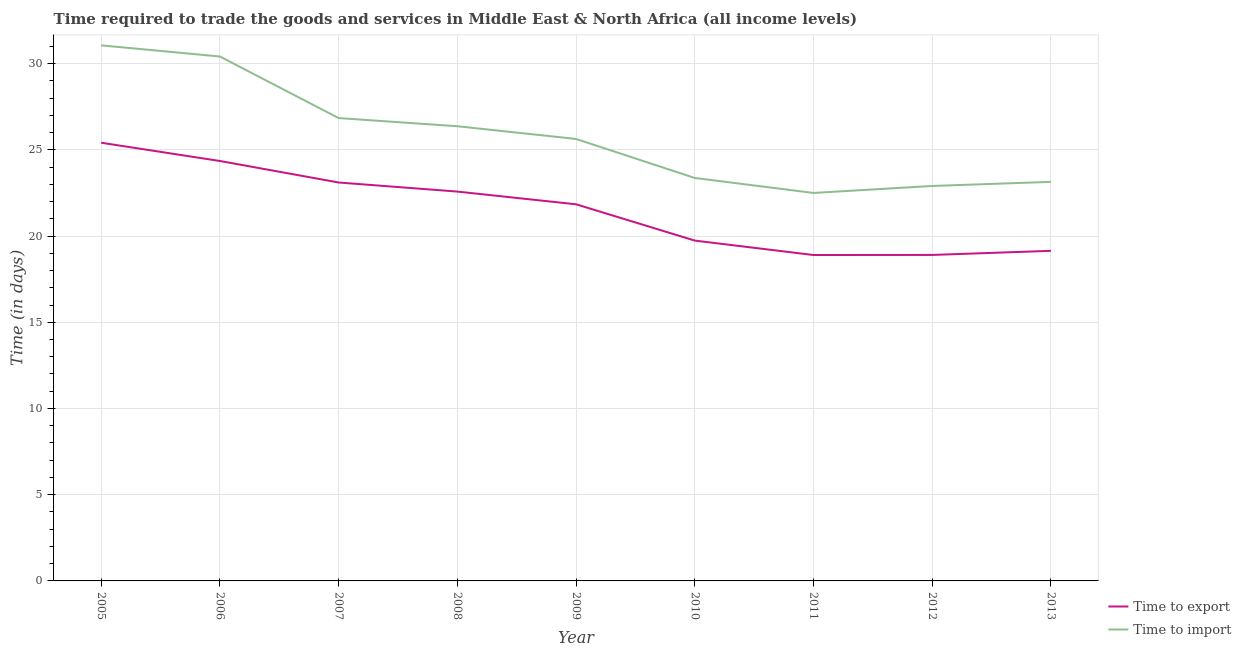How many different coloured lines are there?
Give a very brief answer. 2. Does the line corresponding to time to export intersect with the line corresponding to time to import?
Keep it short and to the point. No. Is the number of lines equal to the number of legend labels?
Keep it short and to the point. Yes. What is the time to export in 2006?
Give a very brief answer. 24.35. Across all years, what is the maximum time to export?
Provide a short and direct response. 25.41. What is the total time to export in the graph?
Give a very brief answer. 193.98. What is the difference between the time to export in 2008 and that in 2011?
Provide a short and direct response. 3.68. What is the difference between the time to import in 2007 and the time to export in 2008?
Give a very brief answer. 4.26. What is the average time to export per year?
Provide a short and direct response. 21.55. In the year 2008, what is the difference between the time to export and time to import?
Offer a terse response. -3.79. What is the ratio of the time to import in 2008 to that in 2013?
Ensure brevity in your answer.  1.14. Is the difference between the time to export in 2010 and 2012 greater than the difference between the time to import in 2010 and 2012?
Offer a terse response. Yes. What is the difference between the highest and the second highest time to import?
Offer a very short reply. 0.65. What is the difference between the highest and the lowest time to export?
Your answer should be compact. 6.51. In how many years, is the time to import greater than the average time to import taken over all years?
Provide a succinct answer. 4. Is the sum of the time to import in 2007 and 2011 greater than the maximum time to export across all years?
Your answer should be compact. Yes. Does the time to import monotonically increase over the years?
Offer a terse response. No. Is the time to import strictly less than the time to export over the years?
Offer a terse response. No. How many lines are there?
Offer a very short reply. 2. What is the difference between two consecutive major ticks on the Y-axis?
Provide a succinct answer. 5. Are the values on the major ticks of Y-axis written in scientific E-notation?
Your answer should be very brief. No. Does the graph contain grids?
Offer a terse response. Yes. How many legend labels are there?
Offer a very short reply. 2. What is the title of the graph?
Your answer should be compact. Time required to trade the goods and services in Middle East & North Africa (all income levels). What is the label or title of the X-axis?
Your response must be concise. Year. What is the label or title of the Y-axis?
Offer a very short reply. Time (in days). What is the Time (in days) in Time to export in 2005?
Offer a very short reply. 25.41. What is the Time (in days) of Time to import in 2005?
Offer a terse response. 31.06. What is the Time (in days) in Time to export in 2006?
Offer a terse response. 24.35. What is the Time (in days) in Time to import in 2006?
Your response must be concise. 30.41. What is the Time (in days) in Time to export in 2007?
Offer a very short reply. 23.11. What is the Time (in days) of Time to import in 2007?
Your response must be concise. 26.84. What is the Time (in days) of Time to export in 2008?
Offer a very short reply. 22.58. What is the Time (in days) in Time to import in 2008?
Your response must be concise. 26.37. What is the Time (in days) of Time to export in 2009?
Offer a terse response. 21.84. What is the Time (in days) of Time to import in 2009?
Keep it short and to the point. 25.63. What is the Time (in days) of Time to export in 2010?
Your response must be concise. 19.74. What is the Time (in days) of Time to import in 2010?
Provide a short and direct response. 23.37. What is the Time (in days) in Time to export in 2012?
Provide a succinct answer. 18.9. What is the Time (in days) of Time to import in 2012?
Ensure brevity in your answer.  22.9. What is the Time (in days) of Time to export in 2013?
Your answer should be compact. 19.14. What is the Time (in days) in Time to import in 2013?
Your answer should be compact. 23.14. Across all years, what is the maximum Time (in days) of Time to export?
Your answer should be compact. 25.41. Across all years, what is the maximum Time (in days) in Time to import?
Make the answer very short. 31.06. Across all years, what is the minimum Time (in days) in Time to import?
Provide a succinct answer. 22.5. What is the total Time (in days) of Time to export in the graph?
Your response must be concise. 193.98. What is the total Time (in days) in Time to import in the graph?
Offer a very short reply. 232.23. What is the difference between the Time (in days) in Time to export in 2005 and that in 2006?
Offer a terse response. 1.06. What is the difference between the Time (in days) in Time to import in 2005 and that in 2006?
Your response must be concise. 0.65. What is the difference between the Time (in days) in Time to export in 2005 and that in 2007?
Give a very brief answer. 2.31. What is the difference between the Time (in days) in Time to import in 2005 and that in 2007?
Make the answer very short. 4.22. What is the difference between the Time (in days) of Time to export in 2005 and that in 2008?
Offer a very short reply. 2.83. What is the difference between the Time (in days) of Time to import in 2005 and that in 2008?
Provide a succinct answer. 4.69. What is the difference between the Time (in days) of Time to export in 2005 and that in 2009?
Offer a terse response. 3.57. What is the difference between the Time (in days) of Time to import in 2005 and that in 2009?
Keep it short and to the point. 5.43. What is the difference between the Time (in days) in Time to export in 2005 and that in 2010?
Keep it short and to the point. 5.67. What is the difference between the Time (in days) in Time to import in 2005 and that in 2010?
Provide a succinct answer. 7.69. What is the difference between the Time (in days) in Time to export in 2005 and that in 2011?
Keep it short and to the point. 6.51. What is the difference between the Time (in days) of Time to import in 2005 and that in 2011?
Ensure brevity in your answer.  8.56. What is the difference between the Time (in days) of Time to export in 2005 and that in 2012?
Offer a very short reply. 6.51. What is the difference between the Time (in days) in Time to import in 2005 and that in 2012?
Ensure brevity in your answer.  8.15. What is the difference between the Time (in days) of Time to export in 2005 and that in 2013?
Offer a very short reply. 6.27. What is the difference between the Time (in days) of Time to import in 2005 and that in 2013?
Your answer should be very brief. 7.92. What is the difference between the Time (in days) of Time to export in 2006 and that in 2007?
Provide a succinct answer. 1.25. What is the difference between the Time (in days) in Time to import in 2006 and that in 2007?
Your answer should be very brief. 3.57. What is the difference between the Time (in days) in Time to export in 2006 and that in 2008?
Provide a succinct answer. 1.77. What is the difference between the Time (in days) of Time to import in 2006 and that in 2008?
Keep it short and to the point. 4.04. What is the difference between the Time (in days) of Time to export in 2006 and that in 2009?
Ensure brevity in your answer.  2.51. What is the difference between the Time (in days) of Time to import in 2006 and that in 2009?
Offer a terse response. 4.78. What is the difference between the Time (in days) of Time to export in 2006 and that in 2010?
Offer a very short reply. 4.62. What is the difference between the Time (in days) of Time to import in 2006 and that in 2010?
Keep it short and to the point. 7.04. What is the difference between the Time (in days) of Time to export in 2006 and that in 2011?
Your response must be concise. 5.45. What is the difference between the Time (in days) in Time to import in 2006 and that in 2011?
Ensure brevity in your answer.  7.91. What is the difference between the Time (in days) in Time to export in 2006 and that in 2012?
Your answer should be very brief. 5.45. What is the difference between the Time (in days) in Time to import in 2006 and that in 2012?
Your response must be concise. 7.51. What is the difference between the Time (in days) in Time to export in 2006 and that in 2013?
Offer a very short reply. 5.21. What is the difference between the Time (in days) of Time to import in 2006 and that in 2013?
Your response must be concise. 7.27. What is the difference between the Time (in days) in Time to export in 2007 and that in 2008?
Ensure brevity in your answer.  0.53. What is the difference between the Time (in days) of Time to import in 2007 and that in 2008?
Your answer should be very brief. 0.47. What is the difference between the Time (in days) in Time to export in 2007 and that in 2009?
Make the answer very short. 1.26. What is the difference between the Time (in days) of Time to import in 2007 and that in 2009?
Keep it short and to the point. 1.21. What is the difference between the Time (in days) of Time to export in 2007 and that in 2010?
Offer a terse response. 3.37. What is the difference between the Time (in days) of Time to import in 2007 and that in 2010?
Keep it short and to the point. 3.47. What is the difference between the Time (in days) in Time to export in 2007 and that in 2011?
Provide a short and direct response. 4.21. What is the difference between the Time (in days) in Time to import in 2007 and that in 2011?
Offer a very short reply. 4.34. What is the difference between the Time (in days) of Time to export in 2007 and that in 2012?
Make the answer very short. 4.2. What is the difference between the Time (in days) in Time to import in 2007 and that in 2012?
Your answer should be very brief. 3.94. What is the difference between the Time (in days) of Time to export in 2007 and that in 2013?
Offer a very short reply. 3.96. What is the difference between the Time (in days) of Time to import in 2007 and that in 2013?
Provide a succinct answer. 3.7. What is the difference between the Time (in days) in Time to export in 2008 and that in 2009?
Provide a succinct answer. 0.74. What is the difference between the Time (in days) in Time to import in 2008 and that in 2009?
Provide a short and direct response. 0.74. What is the difference between the Time (in days) in Time to export in 2008 and that in 2010?
Keep it short and to the point. 2.84. What is the difference between the Time (in days) in Time to import in 2008 and that in 2010?
Keep it short and to the point. 3. What is the difference between the Time (in days) of Time to export in 2008 and that in 2011?
Provide a short and direct response. 3.68. What is the difference between the Time (in days) in Time to import in 2008 and that in 2011?
Provide a short and direct response. 3.87. What is the difference between the Time (in days) of Time to export in 2008 and that in 2012?
Provide a short and direct response. 3.67. What is the difference between the Time (in days) of Time to import in 2008 and that in 2012?
Offer a very short reply. 3.46. What is the difference between the Time (in days) of Time to export in 2008 and that in 2013?
Your response must be concise. 3.44. What is the difference between the Time (in days) of Time to import in 2008 and that in 2013?
Offer a very short reply. 3.23. What is the difference between the Time (in days) in Time to export in 2009 and that in 2010?
Offer a very short reply. 2.11. What is the difference between the Time (in days) of Time to import in 2009 and that in 2010?
Offer a very short reply. 2.26. What is the difference between the Time (in days) in Time to export in 2009 and that in 2011?
Ensure brevity in your answer.  2.94. What is the difference between the Time (in days) in Time to import in 2009 and that in 2011?
Give a very brief answer. 3.13. What is the difference between the Time (in days) in Time to export in 2009 and that in 2012?
Give a very brief answer. 2.94. What is the difference between the Time (in days) of Time to import in 2009 and that in 2012?
Offer a very short reply. 2.73. What is the difference between the Time (in days) of Time to export in 2009 and that in 2013?
Provide a succinct answer. 2.7. What is the difference between the Time (in days) of Time to import in 2009 and that in 2013?
Offer a terse response. 2.49. What is the difference between the Time (in days) of Time to export in 2010 and that in 2011?
Your response must be concise. 0.84. What is the difference between the Time (in days) of Time to import in 2010 and that in 2011?
Provide a short and direct response. 0.87. What is the difference between the Time (in days) of Time to export in 2010 and that in 2012?
Offer a very short reply. 0.83. What is the difference between the Time (in days) of Time to import in 2010 and that in 2012?
Provide a short and direct response. 0.46. What is the difference between the Time (in days) in Time to export in 2010 and that in 2013?
Your answer should be compact. 0.59. What is the difference between the Time (in days) of Time to import in 2010 and that in 2013?
Your answer should be very brief. 0.23. What is the difference between the Time (in days) in Time to export in 2011 and that in 2012?
Your response must be concise. -0. What is the difference between the Time (in days) in Time to import in 2011 and that in 2012?
Your answer should be compact. -0.4. What is the difference between the Time (in days) of Time to export in 2011 and that in 2013?
Your answer should be very brief. -0.24. What is the difference between the Time (in days) of Time to import in 2011 and that in 2013?
Offer a terse response. -0.64. What is the difference between the Time (in days) of Time to export in 2012 and that in 2013?
Provide a succinct answer. -0.24. What is the difference between the Time (in days) in Time to import in 2012 and that in 2013?
Provide a short and direct response. -0.24. What is the difference between the Time (in days) of Time to export in 2005 and the Time (in days) of Time to import in 2006?
Offer a terse response. -5. What is the difference between the Time (in days) in Time to export in 2005 and the Time (in days) in Time to import in 2007?
Provide a short and direct response. -1.43. What is the difference between the Time (in days) in Time to export in 2005 and the Time (in days) in Time to import in 2008?
Make the answer very short. -0.96. What is the difference between the Time (in days) in Time to export in 2005 and the Time (in days) in Time to import in 2009?
Provide a succinct answer. -0.22. What is the difference between the Time (in days) in Time to export in 2005 and the Time (in days) in Time to import in 2010?
Your response must be concise. 2.04. What is the difference between the Time (in days) of Time to export in 2005 and the Time (in days) of Time to import in 2011?
Provide a short and direct response. 2.91. What is the difference between the Time (in days) of Time to export in 2005 and the Time (in days) of Time to import in 2012?
Your answer should be very brief. 2.51. What is the difference between the Time (in days) of Time to export in 2005 and the Time (in days) of Time to import in 2013?
Give a very brief answer. 2.27. What is the difference between the Time (in days) of Time to export in 2006 and the Time (in days) of Time to import in 2007?
Give a very brief answer. -2.49. What is the difference between the Time (in days) of Time to export in 2006 and the Time (in days) of Time to import in 2008?
Ensure brevity in your answer.  -2.02. What is the difference between the Time (in days) of Time to export in 2006 and the Time (in days) of Time to import in 2009?
Your answer should be very brief. -1.28. What is the difference between the Time (in days) in Time to export in 2006 and the Time (in days) in Time to import in 2010?
Offer a terse response. 0.98. What is the difference between the Time (in days) of Time to export in 2006 and the Time (in days) of Time to import in 2011?
Give a very brief answer. 1.85. What is the difference between the Time (in days) in Time to export in 2006 and the Time (in days) in Time to import in 2012?
Your answer should be very brief. 1.45. What is the difference between the Time (in days) in Time to export in 2006 and the Time (in days) in Time to import in 2013?
Make the answer very short. 1.21. What is the difference between the Time (in days) in Time to export in 2007 and the Time (in days) in Time to import in 2008?
Make the answer very short. -3.26. What is the difference between the Time (in days) of Time to export in 2007 and the Time (in days) of Time to import in 2009?
Offer a terse response. -2.53. What is the difference between the Time (in days) in Time to export in 2007 and the Time (in days) in Time to import in 2010?
Keep it short and to the point. -0.26. What is the difference between the Time (in days) in Time to export in 2007 and the Time (in days) in Time to import in 2011?
Offer a terse response. 0.61. What is the difference between the Time (in days) in Time to export in 2007 and the Time (in days) in Time to import in 2012?
Provide a succinct answer. 0.2. What is the difference between the Time (in days) of Time to export in 2007 and the Time (in days) of Time to import in 2013?
Your answer should be very brief. -0.04. What is the difference between the Time (in days) in Time to export in 2008 and the Time (in days) in Time to import in 2009?
Give a very brief answer. -3.05. What is the difference between the Time (in days) of Time to export in 2008 and the Time (in days) of Time to import in 2010?
Make the answer very short. -0.79. What is the difference between the Time (in days) of Time to export in 2008 and the Time (in days) of Time to import in 2011?
Give a very brief answer. 0.08. What is the difference between the Time (in days) in Time to export in 2008 and the Time (in days) in Time to import in 2012?
Your answer should be very brief. -0.33. What is the difference between the Time (in days) in Time to export in 2008 and the Time (in days) in Time to import in 2013?
Keep it short and to the point. -0.56. What is the difference between the Time (in days) in Time to export in 2009 and the Time (in days) in Time to import in 2010?
Provide a short and direct response. -1.53. What is the difference between the Time (in days) in Time to export in 2009 and the Time (in days) in Time to import in 2011?
Offer a terse response. -0.66. What is the difference between the Time (in days) in Time to export in 2009 and the Time (in days) in Time to import in 2012?
Provide a succinct answer. -1.06. What is the difference between the Time (in days) of Time to export in 2009 and the Time (in days) of Time to import in 2013?
Your answer should be compact. -1.3. What is the difference between the Time (in days) of Time to export in 2010 and the Time (in days) of Time to import in 2011?
Offer a terse response. -2.76. What is the difference between the Time (in days) in Time to export in 2010 and the Time (in days) in Time to import in 2012?
Your answer should be very brief. -3.17. What is the difference between the Time (in days) of Time to export in 2010 and the Time (in days) of Time to import in 2013?
Ensure brevity in your answer.  -3.41. What is the difference between the Time (in days) in Time to export in 2011 and the Time (in days) in Time to import in 2012?
Your answer should be compact. -4. What is the difference between the Time (in days) in Time to export in 2011 and the Time (in days) in Time to import in 2013?
Provide a succinct answer. -4.24. What is the difference between the Time (in days) of Time to export in 2012 and the Time (in days) of Time to import in 2013?
Offer a terse response. -4.24. What is the average Time (in days) in Time to export per year?
Your answer should be very brief. 21.55. What is the average Time (in days) of Time to import per year?
Give a very brief answer. 25.8. In the year 2005, what is the difference between the Time (in days) of Time to export and Time (in days) of Time to import?
Your answer should be very brief. -5.65. In the year 2006, what is the difference between the Time (in days) of Time to export and Time (in days) of Time to import?
Your response must be concise. -6.06. In the year 2007, what is the difference between the Time (in days) of Time to export and Time (in days) of Time to import?
Offer a very short reply. -3.74. In the year 2008, what is the difference between the Time (in days) in Time to export and Time (in days) in Time to import?
Your response must be concise. -3.79. In the year 2009, what is the difference between the Time (in days) in Time to export and Time (in days) in Time to import?
Offer a very short reply. -3.79. In the year 2010, what is the difference between the Time (in days) of Time to export and Time (in days) of Time to import?
Ensure brevity in your answer.  -3.63. In the year 2012, what is the difference between the Time (in days) in Time to export and Time (in days) in Time to import?
Ensure brevity in your answer.  -4. In the year 2013, what is the difference between the Time (in days) of Time to export and Time (in days) of Time to import?
Offer a terse response. -4. What is the ratio of the Time (in days) of Time to export in 2005 to that in 2006?
Provide a short and direct response. 1.04. What is the ratio of the Time (in days) in Time to import in 2005 to that in 2006?
Your answer should be very brief. 1.02. What is the ratio of the Time (in days) in Time to export in 2005 to that in 2007?
Offer a very short reply. 1.1. What is the ratio of the Time (in days) in Time to import in 2005 to that in 2007?
Offer a terse response. 1.16. What is the ratio of the Time (in days) in Time to export in 2005 to that in 2008?
Provide a succinct answer. 1.13. What is the ratio of the Time (in days) of Time to import in 2005 to that in 2008?
Ensure brevity in your answer.  1.18. What is the ratio of the Time (in days) in Time to export in 2005 to that in 2009?
Your response must be concise. 1.16. What is the ratio of the Time (in days) in Time to import in 2005 to that in 2009?
Ensure brevity in your answer.  1.21. What is the ratio of the Time (in days) of Time to export in 2005 to that in 2010?
Your answer should be very brief. 1.29. What is the ratio of the Time (in days) of Time to import in 2005 to that in 2010?
Make the answer very short. 1.33. What is the ratio of the Time (in days) of Time to export in 2005 to that in 2011?
Ensure brevity in your answer.  1.34. What is the ratio of the Time (in days) in Time to import in 2005 to that in 2011?
Ensure brevity in your answer.  1.38. What is the ratio of the Time (in days) of Time to export in 2005 to that in 2012?
Your answer should be very brief. 1.34. What is the ratio of the Time (in days) of Time to import in 2005 to that in 2012?
Ensure brevity in your answer.  1.36. What is the ratio of the Time (in days) in Time to export in 2005 to that in 2013?
Your answer should be compact. 1.33. What is the ratio of the Time (in days) of Time to import in 2005 to that in 2013?
Keep it short and to the point. 1.34. What is the ratio of the Time (in days) in Time to export in 2006 to that in 2007?
Offer a terse response. 1.05. What is the ratio of the Time (in days) in Time to import in 2006 to that in 2007?
Your response must be concise. 1.13. What is the ratio of the Time (in days) in Time to export in 2006 to that in 2008?
Provide a short and direct response. 1.08. What is the ratio of the Time (in days) in Time to import in 2006 to that in 2008?
Make the answer very short. 1.15. What is the ratio of the Time (in days) in Time to export in 2006 to that in 2009?
Offer a very short reply. 1.11. What is the ratio of the Time (in days) in Time to import in 2006 to that in 2009?
Your answer should be compact. 1.19. What is the ratio of the Time (in days) in Time to export in 2006 to that in 2010?
Ensure brevity in your answer.  1.23. What is the ratio of the Time (in days) in Time to import in 2006 to that in 2010?
Offer a terse response. 1.3. What is the ratio of the Time (in days) in Time to export in 2006 to that in 2011?
Provide a succinct answer. 1.29. What is the ratio of the Time (in days) of Time to import in 2006 to that in 2011?
Your answer should be very brief. 1.35. What is the ratio of the Time (in days) in Time to export in 2006 to that in 2012?
Offer a terse response. 1.29. What is the ratio of the Time (in days) in Time to import in 2006 to that in 2012?
Give a very brief answer. 1.33. What is the ratio of the Time (in days) in Time to export in 2006 to that in 2013?
Ensure brevity in your answer.  1.27. What is the ratio of the Time (in days) of Time to import in 2006 to that in 2013?
Offer a very short reply. 1.31. What is the ratio of the Time (in days) of Time to export in 2007 to that in 2008?
Keep it short and to the point. 1.02. What is the ratio of the Time (in days) in Time to export in 2007 to that in 2009?
Your answer should be compact. 1.06. What is the ratio of the Time (in days) of Time to import in 2007 to that in 2009?
Give a very brief answer. 1.05. What is the ratio of the Time (in days) of Time to export in 2007 to that in 2010?
Provide a short and direct response. 1.17. What is the ratio of the Time (in days) of Time to import in 2007 to that in 2010?
Offer a very short reply. 1.15. What is the ratio of the Time (in days) in Time to export in 2007 to that in 2011?
Make the answer very short. 1.22. What is the ratio of the Time (in days) in Time to import in 2007 to that in 2011?
Offer a terse response. 1.19. What is the ratio of the Time (in days) in Time to export in 2007 to that in 2012?
Your answer should be very brief. 1.22. What is the ratio of the Time (in days) of Time to import in 2007 to that in 2012?
Ensure brevity in your answer.  1.17. What is the ratio of the Time (in days) of Time to export in 2007 to that in 2013?
Your answer should be very brief. 1.21. What is the ratio of the Time (in days) in Time to import in 2007 to that in 2013?
Provide a short and direct response. 1.16. What is the ratio of the Time (in days) of Time to export in 2008 to that in 2009?
Offer a terse response. 1.03. What is the ratio of the Time (in days) of Time to import in 2008 to that in 2009?
Offer a terse response. 1.03. What is the ratio of the Time (in days) of Time to export in 2008 to that in 2010?
Provide a succinct answer. 1.14. What is the ratio of the Time (in days) in Time to import in 2008 to that in 2010?
Keep it short and to the point. 1.13. What is the ratio of the Time (in days) in Time to export in 2008 to that in 2011?
Make the answer very short. 1.19. What is the ratio of the Time (in days) in Time to import in 2008 to that in 2011?
Ensure brevity in your answer.  1.17. What is the ratio of the Time (in days) in Time to export in 2008 to that in 2012?
Your response must be concise. 1.19. What is the ratio of the Time (in days) of Time to import in 2008 to that in 2012?
Give a very brief answer. 1.15. What is the ratio of the Time (in days) in Time to export in 2008 to that in 2013?
Your answer should be compact. 1.18. What is the ratio of the Time (in days) of Time to import in 2008 to that in 2013?
Your response must be concise. 1.14. What is the ratio of the Time (in days) of Time to export in 2009 to that in 2010?
Keep it short and to the point. 1.11. What is the ratio of the Time (in days) of Time to import in 2009 to that in 2010?
Your response must be concise. 1.1. What is the ratio of the Time (in days) in Time to export in 2009 to that in 2011?
Your answer should be compact. 1.16. What is the ratio of the Time (in days) of Time to import in 2009 to that in 2011?
Offer a very short reply. 1.14. What is the ratio of the Time (in days) of Time to export in 2009 to that in 2012?
Make the answer very short. 1.16. What is the ratio of the Time (in days) of Time to import in 2009 to that in 2012?
Your answer should be compact. 1.12. What is the ratio of the Time (in days) in Time to export in 2009 to that in 2013?
Keep it short and to the point. 1.14. What is the ratio of the Time (in days) in Time to import in 2009 to that in 2013?
Your answer should be very brief. 1.11. What is the ratio of the Time (in days) in Time to export in 2010 to that in 2011?
Offer a terse response. 1.04. What is the ratio of the Time (in days) in Time to import in 2010 to that in 2011?
Provide a succinct answer. 1.04. What is the ratio of the Time (in days) in Time to export in 2010 to that in 2012?
Provide a short and direct response. 1.04. What is the ratio of the Time (in days) of Time to import in 2010 to that in 2012?
Provide a succinct answer. 1.02. What is the ratio of the Time (in days) in Time to export in 2010 to that in 2013?
Your answer should be very brief. 1.03. What is the ratio of the Time (in days) in Time to import in 2010 to that in 2013?
Provide a succinct answer. 1.01. What is the ratio of the Time (in days) of Time to import in 2011 to that in 2012?
Ensure brevity in your answer.  0.98. What is the ratio of the Time (in days) in Time to export in 2011 to that in 2013?
Make the answer very short. 0.99. What is the ratio of the Time (in days) in Time to import in 2011 to that in 2013?
Make the answer very short. 0.97. What is the ratio of the Time (in days) in Time to export in 2012 to that in 2013?
Provide a short and direct response. 0.99. What is the ratio of the Time (in days) in Time to import in 2012 to that in 2013?
Make the answer very short. 0.99. What is the difference between the highest and the second highest Time (in days) of Time to export?
Provide a short and direct response. 1.06. What is the difference between the highest and the second highest Time (in days) of Time to import?
Keep it short and to the point. 0.65. What is the difference between the highest and the lowest Time (in days) of Time to export?
Make the answer very short. 6.51. What is the difference between the highest and the lowest Time (in days) in Time to import?
Offer a terse response. 8.56. 